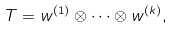Convert formula to latex. <formula><loc_0><loc_0><loc_500><loc_500>T = w ^ { ( 1 ) } \otimes \cdots \otimes w ^ { ( k ) } ,</formula> 